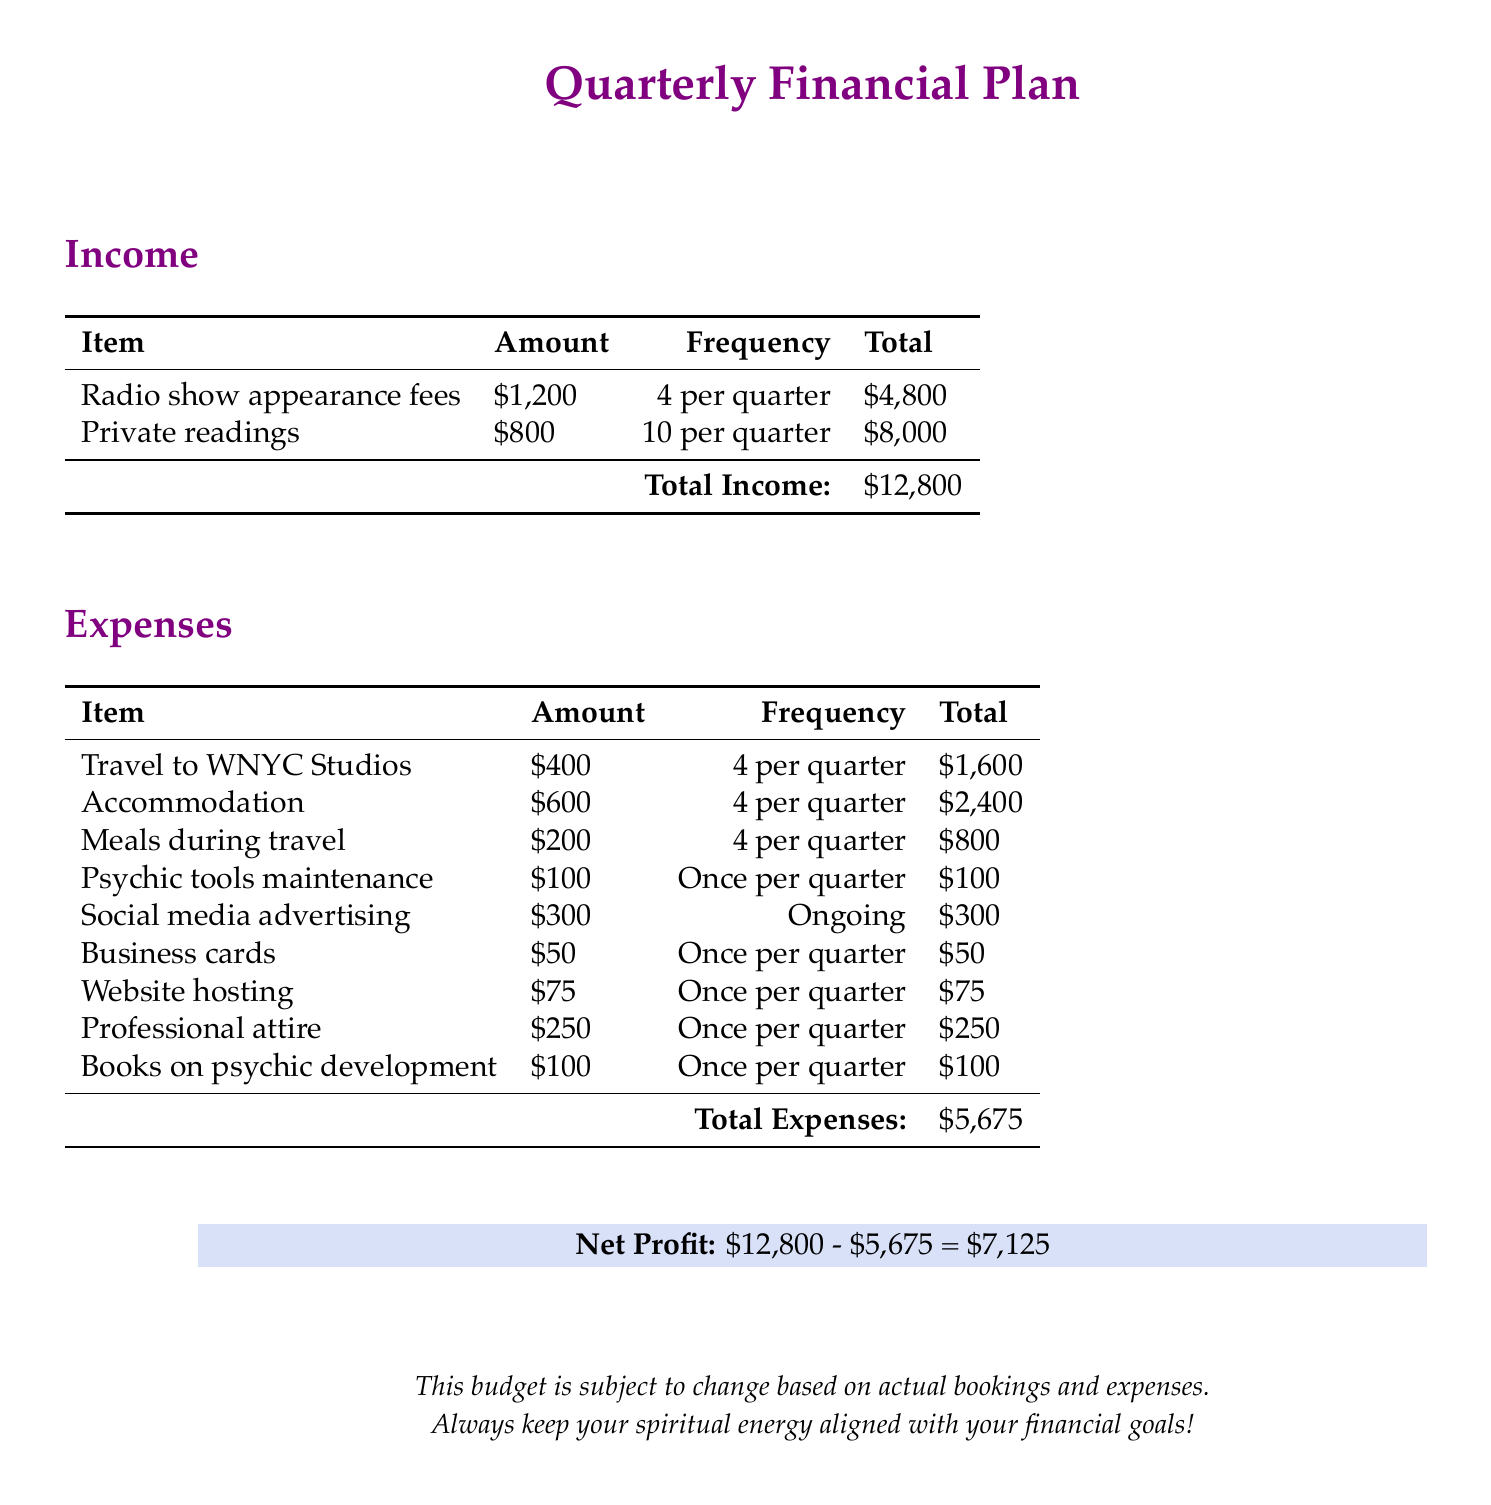What is the total income? The total income is the sum of all income sources in the document, which is $4,800 + $8,000 = $12,800.
Answer: $12,800 What is the total expense? The total expense is the sum of all expenses listed in the document, which totals to $5,675.
Answer: $5,675 What are the travel expenses for one appearance? The travel expense for one appearance to WNYC Studios is $400, as stated in the expenses table.
Answer: $400 How many private readings are included in the plan? The plan includes 10 private readings per quarter as specified in the income section.
Answer: 10 What is the net profit? The net profit is calculated as total income minus total expenses, which is $12,800 - $5,675 = $7,125.
Answer: $7,125 How much is allocated for professional attire per quarter? The allocation for professional attire per quarter is $250 according to the expenses section.
Answer: $250 What is the frequency of social media advertising expenses? The frequency for social media advertising is marked as ongoing in the expenses table.
Answer: Ongoing How much will be spent on accommodation during travel? The total amount to be spent on accommodation for the quarter is $2,400, calculated as $600 for each of the 4 appearances.
Answer: $2,400 What is the total cost for psychic tools maintenance? The total cost for psychic tools maintenance is $100, as it occurs once per quarter.
Answer: $100 How much do the books on psychic development cost? The expense for books on psychic development is noted as $100 for each quarter.
Answer: $100 